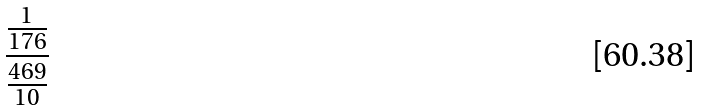Convert formula to latex. <formula><loc_0><loc_0><loc_500><loc_500>\frac { \frac { 1 } { 1 7 6 } } { \frac { 4 6 9 } { 1 0 } }</formula> 